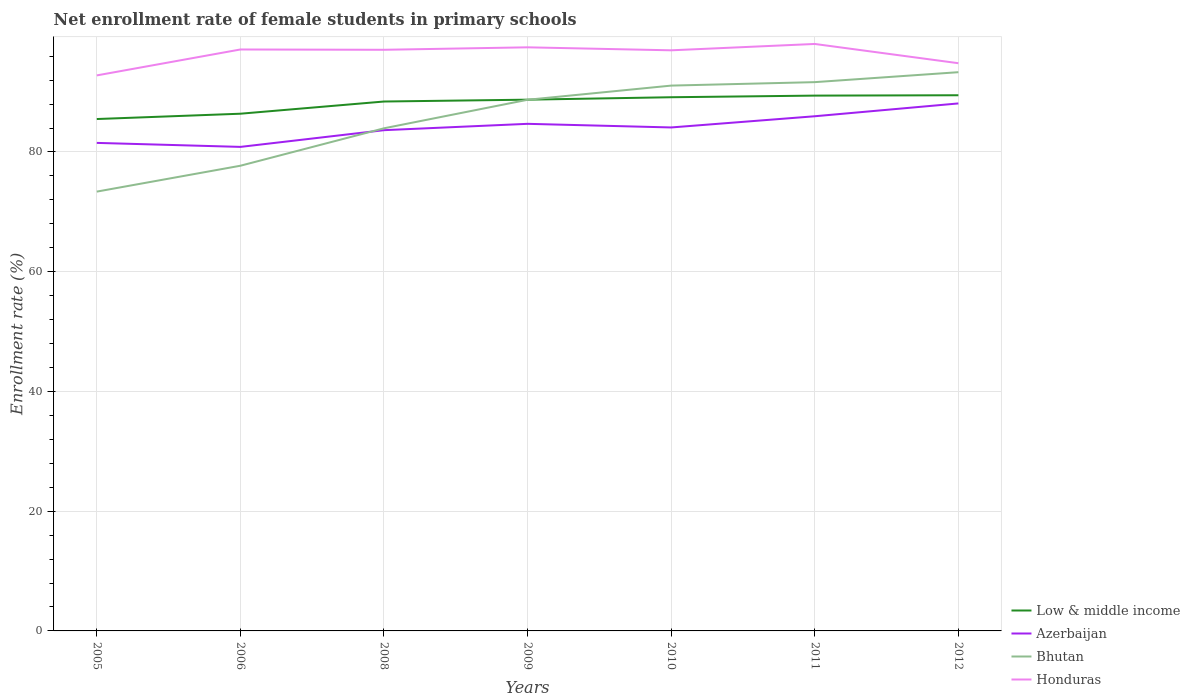How many different coloured lines are there?
Your answer should be very brief. 4. Across all years, what is the maximum net enrollment rate of female students in primary schools in Azerbaijan?
Ensure brevity in your answer.  80.85. In which year was the net enrollment rate of female students in primary schools in Azerbaijan maximum?
Your answer should be very brief. 2006. What is the total net enrollment rate of female students in primary schools in Low & middle income in the graph?
Provide a short and direct response. -3.02. What is the difference between the highest and the second highest net enrollment rate of female students in primary schools in Low & middle income?
Your response must be concise. 3.97. What is the difference between the highest and the lowest net enrollment rate of female students in primary schools in Low & middle income?
Make the answer very short. 5. Is the net enrollment rate of female students in primary schools in Azerbaijan strictly greater than the net enrollment rate of female students in primary schools in Bhutan over the years?
Provide a succinct answer. No. What is the difference between two consecutive major ticks on the Y-axis?
Ensure brevity in your answer.  20. Are the values on the major ticks of Y-axis written in scientific E-notation?
Give a very brief answer. No. Where does the legend appear in the graph?
Give a very brief answer. Bottom right. What is the title of the graph?
Keep it short and to the point. Net enrollment rate of female students in primary schools. What is the label or title of the Y-axis?
Provide a succinct answer. Enrollment rate (%). What is the Enrollment rate (%) of Low & middle income in 2005?
Your answer should be compact. 85.5. What is the Enrollment rate (%) in Azerbaijan in 2005?
Ensure brevity in your answer.  81.52. What is the Enrollment rate (%) of Bhutan in 2005?
Provide a short and direct response. 73.38. What is the Enrollment rate (%) in Honduras in 2005?
Make the answer very short. 92.79. What is the Enrollment rate (%) of Low & middle income in 2006?
Ensure brevity in your answer.  86.39. What is the Enrollment rate (%) in Azerbaijan in 2006?
Provide a succinct answer. 80.85. What is the Enrollment rate (%) in Bhutan in 2006?
Offer a terse response. 77.7. What is the Enrollment rate (%) in Honduras in 2006?
Give a very brief answer. 97.12. What is the Enrollment rate (%) in Low & middle income in 2008?
Make the answer very short. 88.43. What is the Enrollment rate (%) in Azerbaijan in 2008?
Keep it short and to the point. 83.64. What is the Enrollment rate (%) of Bhutan in 2008?
Offer a very short reply. 83.95. What is the Enrollment rate (%) in Honduras in 2008?
Make the answer very short. 97.07. What is the Enrollment rate (%) of Low & middle income in 2009?
Provide a short and direct response. 88.74. What is the Enrollment rate (%) in Azerbaijan in 2009?
Keep it short and to the point. 84.7. What is the Enrollment rate (%) in Bhutan in 2009?
Give a very brief answer. 88.72. What is the Enrollment rate (%) in Honduras in 2009?
Keep it short and to the point. 97.48. What is the Enrollment rate (%) of Low & middle income in 2010?
Keep it short and to the point. 89.14. What is the Enrollment rate (%) in Azerbaijan in 2010?
Your answer should be very brief. 84.09. What is the Enrollment rate (%) in Bhutan in 2010?
Ensure brevity in your answer.  91.09. What is the Enrollment rate (%) in Honduras in 2010?
Keep it short and to the point. 96.98. What is the Enrollment rate (%) in Low & middle income in 2011?
Your response must be concise. 89.41. What is the Enrollment rate (%) of Azerbaijan in 2011?
Provide a succinct answer. 85.97. What is the Enrollment rate (%) of Bhutan in 2011?
Offer a very short reply. 91.66. What is the Enrollment rate (%) in Honduras in 2011?
Offer a terse response. 98.04. What is the Enrollment rate (%) in Low & middle income in 2012?
Keep it short and to the point. 89.47. What is the Enrollment rate (%) of Azerbaijan in 2012?
Your response must be concise. 88.11. What is the Enrollment rate (%) in Bhutan in 2012?
Keep it short and to the point. 93.33. What is the Enrollment rate (%) in Honduras in 2012?
Your response must be concise. 94.82. Across all years, what is the maximum Enrollment rate (%) of Low & middle income?
Keep it short and to the point. 89.47. Across all years, what is the maximum Enrollment rate (%) in Azerbaijan?
Make the answer very short. 88.11. Across all years, what is the maximum Enrollment rate (%) of Bhutan?
Give a very brief answer. 93.33. Across all years, what is the maximum Enrollment rate (%) of Honduras?
Keep it short and to the point. 98.04. Across all years, what is the minimum Enrollment rate (%) of Low & middle income?
Make the answer very short. 85.5. Across all years, what is the minimum Enrollment rate (%) of Azerbaijan?
Give a very brief answer. 80.85. Across all years, what is the minimum Enrollment rate (%) in Bhutan?
Make the answer very short. 73.38. Across all years, what is the minimum Enrollment rate (%) of Honduras?
Make the answer very short. 92.79. What is the total Enrollment rate (%) of Low & middle income in the graph?
Ensure brevity in your answer.  617.08. What is the total Enrollment rate (%) of Azerbaijan in the graph?
Provide a succinct answer. 588.87. What is the total Enrollment rate (%) of Bhutan in the graph?
Keep it short and to the point. 599.83. What is the total Enrollment rate (%) of Honduras in the graph?
Make the answer very short. 674.3. What is the difference between the Enrollment rate (%) of Low & middle income in 2005 and that in 2006?
Give a very brief answer. -0.89. What is the difference between the Enrollment rate (%) of Azerbaijan in 2005 and that in 2006?
Give a very brief answer. 0.67. What is the difference between the Enrollment rate (%) in Bhutan in 2005 and that in 2006?
Provide a succinct answer. -4.32. What is the difference between the Enrollment rate (%) of Honduras in 2005 and that in 2006?
Give a very brief answer. -4.33. What is the difference between the Enrollment rate (%) of Low & middle income in 2005 and that in 2008?
Offer a terse response. -2.93. What is the difference between the Enrollment rate (%) of Azerbaijan in 2005 and that in 2008?
Your answer should be very brief. -2.12. What is the difference between the Enrollment rate (%) in Bhutan in 2005 and that in 2008?
Ensure brevity in your answer.  -10.58. What is the difference between the Enrollment rate (%) in Honduras in 2005 and that in 2008?
Your answer should be very brief. -4.28. What is the difference between the Enrollment rate (%) of Low & middle income in 2005 and that in 2009?
Ensure brevity in your answer.  -3.23. What is the difference between the Enrollment rate (%) in Azerbaijan in 2005 and that in 2009?
Provide a succinct answer. -3.18. What is the difference between the Enrollment rate (%) of Bhutan in 2005 and that in 2009?
Keep it short and to the point. -15.34. What is the difference between the Enrollment rate (%) in Honduras in 2005 and that in 2009?
Your response must be concise. -4.69. What is the difference between the Enrollment rate (%) in Low & middle income in 2005 and that in 2010?
Provide a short and direct response. -3.64. What is the difference between the Enrollment rate (%) in Azerbaijan in 2005 and that in 2010?
Keep it short and to the point. -2.58. What is the difference between the Enrollment rate (%) of Bhutan in 2005 and that in 2010?
Offer a very short reply. -17.71. What is the difference between the Enrollment rate (%) of Honduras in 2005 and that in 2010?
Your answer should be very brief. -4.19. What is the difference between the Enrollment rate (%) in Low & middle income in 2005 and that in 2011?
Provide a succinct answer. -3.91. What is the difference between the Enrollment rate (%) of Azerbaijan in 2005 and that in 2011?
Your answer should be compact. -4.45. What is the difference between the Enrollment rate (%) in Bhutan in 2005 and that in 2011?
Your answer should be very brief. -18.29. What is the difference between the Enrollment rate (%) of Honduras in 2005 and that in 2011?
Ensure brevity in your answer.  -5.25. What is the difference between the Enrollment rate (%) of Low & middle income in 2005 and that in 2012?
Provide a succinct answer. -3.97. What is the difference between the Enrollment rate (%) of Azerbaijan in 2005 and that in 2012?
Your answer should be compact. -6.59. What is the difference between the Enrollment rate (%) in Bhutan in 2005 and that in 2012?
Make the answer very short. -19.95. What is the difference between the Enrollment rate (%) of Honduras in 2005 and that in 2012?
Offer a very short reply. -2.04. What is the difference between the Enrollment rate (%) in Low & middle income in 2006 and that in 2008?
Provide a short and direct response. -2.04. What is the difference between the Enrollment rate (%) of Azerbaijan in 2006 and that in 2008?
Offer a terse response. -2.79. What is the difference between the Enrollment rate (%) of Bhutan in 2006 and that in 2008?
Provide a succinct answer. -6.25. What is the difference between the Enrollment rate (%) in Honduras in 2006 and that in 2008?
Make the answer very short. 0.05. What is the difference between the Enrollment rate (%) of Low & middle income in 2006 and that in 2009?
Offer a very short reply. -2.35. What is the difference between the Enrollment rate (%) of Azerbaijan in 2006 and that in 2009?
Your response must be concise. -3.85. What is the difference between the Enrollment rate (%) in Bhutan in 2006 and that in 2009?
Offer a very short reply. -11.02. What is the difference between the Enrollment rate (%) of Honduras in 2006 and that in 2009?
Your response must be concise. -0.36. What is the difference between the Enrollment rate (%) in Low & middle income in 2006 and that in 2010?
Give a very brief answer. -2.75. What is the difference between the Enrollment rate (%) in Azerbaijan in 2006 and that in 2010?
Provide a succinct answer. -3.25. What is the difference between the Enrollment rate (%) in Bhutan in 2006 and that in 2010?
Your answer should be compact. -13.38. What is the difference between the Enrollment rate (%) in Honduras in 2006 and that in 2010?
Make the answer very short. 0.14. What is the difference between the Enrollment rate (%) in Low & middle income in 2006 and that in 2011?
Your answer should be compact. -3.02. What is the difference between the Enrollment rate (%) in Azerbaijan in 2006 and that in 2011?
Keep it short and to the point. -5.12. What is the difference between the Enrollment rate (%) in Bhutan in 2006 and that in 2011?
Your answer should be very brief. -13.96. What is the difference between the Enrollment rate (%) of Honduras in 2006 and that in 2011?
Provide a short and direct response. -0.92. What is the difference between the Enrollment rate (%) in Low & middle income in 2006 and that in 2012?
Make the answer very short. -3.08. What is the difference between the Enrollment rate (%) of Azerbaijan in 2006 and that in 2012?
Make the answer very short. -7.26. What is the difference between the Enrollment rate (%) in Bhutan in 2006 and that in 2012?
Provide a succinct answer. -15.62. What is the difference between the Enrollment rate (%) of Honduras in 2006 and that in 2012?
Ensure brevity in your answer.  2.29. What is the difference between the Enrollment rate (%) in Low & middle income in 2008 and that in 2009?
Offer a terse response. -0.31. What is the difference between the Enrollment rate (%) in Azerbaijan in 2008 and that in 2009?
Your response must be concise. -1.06. What is the difference between the Enrollment rate (%) of Bhutan in 2008 and that in 2009?
Keep it short and to the point. -4.76. What is the difference between the Enrollment rate (%) in Honduras in 2008 and that in 2009?
Offer a terse response. -0.41. What is the difference between the Enrollment rate (%) of Low & middle income in 2008 and that in 2010?
Make the answer very short. -0.71. What is the difference between the Enrollment rate (%) of Azerbaijan in 2008 and that in 2010?
Your response must be concise. -0.45. What is the difference between the Enrollment rate (%) of Bhutan in 2008 and that in 2010?
Your response must be concise. -7.13. What is the difference between the Enrollment rate (%) of Honduras in 2008 and that in 2010?
Your answer should be compact. 0.09. What is the difference between the Enrollment rate (%) of Low & middle income in 2008 and that in 2011?
Your answer should be compact. -0.99. What is the difference between the Enrollment rate (%) of Azerbaijan in 2008 and that in 2011?
Give a very brief answer. -2.33. What is the difference between the Enrollment rate (%) of Bhutan in 2008 and that in 2011?
Provide a short and direct response. -7.71. What is the difference between the Enrollment rate (%) in Honduras in 2008 and that in 2011?
Ensure brevity in your answer.  -0.97. What is the difference between the Enrollment rate (%) of Low & middle income in 2008 and that in 2012?
Your answer should be very brief. -1.05. What is the difference between the Enrollment rate (%) of Azerbaijan in 2008 and that in 2012?
Offer a terse response. -4.47. What is the difference between the Enrollment rate (%) in Bhutan in 2008 and that in 2012?
Your answer should be very brief. -9.37. What is the difference between the Enrollment rate (%) in Honduras in 2008 and that in 2012?
Offer a terse response. 2.24. What is the difference between the Enrollment rate (%) in Low & middle income in 2009 and that in 2010?
Ensure brevity in your answer.  -0.41. What is the difference between the Enrollment rate (%) of Azerbaijan in 2009 and that in 2010?
Your answer should be compact. 0.61. What is the difference between the Enrollment rate (%) in Bhutan in 2009 and that in 2010?
Offer a terse response. -2.37. What is the difference between the Enrollment rate (%) in Honduras in 2009 and that in 2010?
Your answer should be very brief. 0.5. What is the difference between the Enrollment rate (%) of Low & middle income in 2009 and that in 2011?
Keep it short and to the point. -0.68. What is the difference between the Enrollment rate (%) in Azerbaijan in 2009 and that in 2011?
Make the answer very short. -1.27. What is the difference between the Enrollment rate (%) in Bhutan in 2009 and that in 2011?
Your answer should be very brief. -2.94. What is the difference between the Enrollment rate (%) in Honduras in 2009 and that in 2011?
Provide a succinct answer. -0.56. What is the difference between the Enrollment rate (%) of Low & middle income in 2009 and that in 2012?
Give a very brief answer. -0.74. What is the difference between the Enrollment rate (%) of Azerbaijan in 2009 and that in 2012?
Your answer should be compact. -3.41. What is the difference between the Enrollment rate (%) in Bhutan in 2009 and that in 2012?
Provide a succinct answer. -4.61. What is the difference between the Enrollment rate (%) in Honduras in 2009 and that in 2012?
Offer a very short reply. 2.65. What is the difference between the Enrollment rate (%) of Low & middle income in 2010 and that in 2011?
Ensure brevity in your answer.  -0.27. What is the difference between the Enrollment rate (%) of Azerbaijan in 2010 and that in 2011?
Offer a very short reply. -1.87. What is the difference between the Enrollment rate (%) in Bhutan in 2010 and that in 2011?
Provide a short and direct response. -0.58. What is the difference between the Enrollment rate (%) in Honduras in 2010 and that in 2011?
Your answer should be very brief. -1.06. What is the difference between the Enrollment rate (%) in Low & middle income in 2010 and that in 2012?
Provide a short and direct response. -0.33. What is the difference between the Enrollment rate (%) of Azerbaijan in 2010 and that in 2012?
Offer a very short reply. -4.01. What is the difference between the Enrollment rate (%) in Bhutan in 2010 and that in 2012?
Offer a very short reply. -2.24. What is the difference between the Enrollment rate (%) in Honduras in 2010 and that in 2012?
Give a very brief answer. 2.15. What is the difference between the Enrollment rate (%) in Low & middle income in 2011 and that in 2012?
Ensure brevity in your answer.  -0.06. What is the difference between the Enrollment rate (%) in Azerbaijan in 2011 and that in 2012?
Your answer should be compact. -2.14. What is the difference between the Enrollment rate (%) of Bhutan in 2011 and that in 2012?
Offer a very short reply. -1.66. What is the difference between the Enrollment rate (%) of Honduras in 2011 and that in 2012?
Your answer should be very brief. 3.22. What is the difference between the Enrollment rate (%) in Low & middle income in 2005 and the Enrollment rate (%) in Azerbaijan in 2006?
Your answer should be compact. 4.65. What is the difference between the Enrollment rate (%) of Low & middle income in 2005 and the Enrollment rate (%) of Bhutan in 2006?
Your response must be concise. 7.8. What is the difference between the Enrollment rate (%) in Low & middle income in 2005 and the Enrollment rate (%) in Honduras in 2006?
Offer a very short reply. -11.62. What is the difference between the Enrollment rate (%) in Azerbaijan in 2005 and the Enrollment rate (%) in Bhutan in 2006?
Offer a very short reply. 3.81. What is the difference between the Enrollment rate (%) of Azerbaijan in 2005 and the Enrollment rate (%) of Honduras in 2006?
Ensure brevity in your answer.  -15.6. What is the difference between the Enrollment rate (%) of Bhutan in 2005 and the Enrollment rate (%) of Honduras in 2006?
Offer a terse response. -23.74. What is the difference between the Enrollment rate (%) in Low & middle income in 2005 and the Enrollment rate (%) in Azerbaijan in 2008?
Your answer should be compact. 1.86. What is the difference between the Enrollment rate (%) in Low & middle income in 2005 and the Enrollment rate (%) in Bhutan in 2008?
Give a very brief answer. 1.55. What is the difference between the Enrollment rate (%) of Low & middle income in 2005 and the Enrollment rate (%) of Honduras in 2008?
Give a very brief answer. -11.57. What is the difference between the Enrollment rate (%) in Azerbaijan in 2005 and the Enrollment rate (%) in Bhutan in 2008?
Your response must be concise. -2.44. What is the difference between the Enrollment rate (%) of Azerbaijan in 2005 and the Enrollment rate (%) of Honduras in 2008?
Offer a terse response. -15.55. What is the difference between the Enrollment rate (%) in Bhutan in 2005 and the Enrollment rate (%) in Honduras in 2008?
Ensure brevity in your answer.  -23.69. What is the difference between the Enrollment rate (%) in Low & middle income in 2005 and the Enrollment rate (%) in Azerbaijan in 2009?
Make the answer very short. 0.8. What is the difference between the Enrollment rate (%) in Low & middle income in 2005 and the Enrollment rate (%) in Bhutan in 2009?
Your answer should be very brief. -3.22. What is the difference between the Enrollment rate (%) in Low & middle income in 2005 and the Enrollment rate (%) in Honduras in 2009?
Offer a terse response. -11.98. What is the difference between the Enrollment rate (%) in Azerbaijan in 2005 and the Enrollment rate (%) in Bhutan in 2009?
Your response must be concise. -7.2. What is the difference between the Enrollment rate (%) in Azerbaijan in 2005 and the Enrollment rate (%) in Honduras in 2009?
Your response must be concise. -15.96. What is the difference between the Enrollment rate (%) of Bhutan in 2005 and the Enrollment rate (%) of Honduras in 2009?
Your answer should be very brief. -24.1. What is the difference between the Enrollment rate (%) of Low & middle income in 2005 and the Enrollment rate (%) of Azerbaijan in 2010?
Offer a terse response. 1.41. What is the difference between the Enrollment rate (%) in Low & middle income in 2005 and the Enrollment rate (%) in Bhutan in 2010?
Offer a very short reply. -5.59. What is the difference between the Enrollment rate (%) of Low & middle income in 2005 and the Enrollment rate (%) of Honduras in 2010?
Give a very brief answer. -11.48. What is the difference between the Enrollment rate (%) in Azerbaijan in 2005 and the Enrollment rate (%) in Bhutan in 2010?
Provide a short and direct response. -9.57. What is the difference between the Enrollment rate (%) of Azerbaijan in 2005 and the Enrollment rate (%) of Honduras in 2010?
Keep it short and to the point. -15.46. What is the difference between the Enrollment rate (%) of Bhutan in 2005 and the Enrollment rate (%) of Honduras in 2010?
Provide a succinct answer. -23.6. What is the difference between the Enrollment rate (%) of Low & middle income in 2005 and the Enrollment rate (%) of Azerbaijan in 2011?
Provide a short and direct response. -0.46. What is the difference between the Enrollment rate (%) in Low & middle income in 2005 and the Enrollment rate (%) in Bhutan in 2011?
Your answer should be very brief. -6.16. What is the difference between the Enrollment rate (%) in Low & middle income in 2005 and the Enrollment rate (%) in Honduras in 2011?
Keep it short and to the point. -12.54. What is the difference between the Enrollment rate (%) in Azerbaijan in 2005 and the Enrollment rate (%) in Bhutan in 2011?
Offer a terse response. -10.15. What is the difference between the Enrollment rate (%) in Azerbaijan in 2005 and the Enrollment rate (%) in Honduras in 2011?
Your answer should be compact. -16.52. What is the difference between the Enrollment rate (%) of Bhutan in 2005 and the Enrollment rate (%) of Honduras in 2011?
Offer a very short reply. -24.66. What is the difference between the Enrollment rate (%) of Low & middle income in 2005 and the Enrollment rate (%) of Azerbaijan in 2012?
Your answer should be compact. -2.61. What is the difference between the Enrollment rate (%) of Low & middle income in 2005 and the Enrollment rate (%) of Bhutan in 2012?
Make the answer very short. -7.83. What is the difference between the Enrollment rate (%) in Low & middle income in 2005 and the Enrollment rate (%) in Honduras in 2012?
Offer a very short reply. -9.32. What is the difference between the Enrollment rate (%) of Azerbaijan in 2005 and the Enrollment rate (%) of Bhutan in 2012?
Your response must be concise. -11.81. What is the difference between the Enrollment rate (%) in Azerbaijan in 2005 and the Enrollment rate (%) in Honduras in 2012?
Keep it short and to the point. -13.31. What is the difference between the Enrollment rate (%) of Bhutan in 2005 and the Enrollment rate (%) of Honduras in 2012?
Your answer should be very brief. -21.45. What is the difference between the Enrollment rate (%) of Low & middle income in 2006 and the Enrollment rate (%) of Azerbaijan in 2008?
Keep it short and to the point. 2.75. What is the difference between the Enrollment rate (%) of Low & middle income in 2006 and the Enrollment rate (%) of Bhutan in 2008?
Provide a succinct answer. 2.43. What is the difference between the Enrollment rate (%) in Low & middle income in 2006 and the Enrollment rate (%) in Honduras in 2008?
Offer a terse response. -10.68. What is the difference between the Enrollment rate (%) of Azerbaijan in 2006 and the Enrollment rate (%) of Bhutan in 2008?
Make the answer very short. -3.11. What is the difference between the Enrollment rate (%) of Azerbaijan in 2006 and the Enrollment rate (%) of Honduras in 2008?
Offer a very short reply. -16.22. What is the difference between the Enrollment rate (%) of Bhutan in 2006 and the Enrollment rate (%) of Honduras in 2008?
Keep it short and to the point. -19.37. What is the difference between the Enrollment rate (%) of Low & middle income in 2006 and the Enrollment rate (%) of Azerbaijan in 2009?
Give a very brief answer. 1.69. What is the difference between the Enrollment rate (%) of Low & middle income in 2006 and the Enrollment rate (%) of Bhutan in 2009?
Your answer should be very brief. -2.33. What is the difference between the Enrollment rate (%) in Low & middle income in 2006 and the Enrollment rate (%) in Honduras in 2009?
Your response must be concise. -11.09. What is the difference between the Enrollment rate (%) of Azerbaijan in 2006 and the Enrollment rate (%) of Bhutan in 2009?
Provide a short and direct response. -7.87. What is the difference between the Enrollment rate (%) of Azerbaijan in 2006 and the Enrollment rate (%) of Honduras in 2009?
Your answer should be compact. -16.63. What is the difference between the Enrollment rate (%) in Bhutan in 2006 and the Enrollment rate (%) in Honduras in 2009?
Ensure brevity in your answer.  -19.78. What is the difference between the Enrollment rate (%) in Low & middle income in 2006 and the Enrollment rate (%) in Azerbaijan in 2010?
Offer a very short reply. 2.3. What is the difference between the Enrollment rate (%) of Low & middle income in 2006 and the Enrollment rate (%) of Bhutan in 2010?
Give a very brief answer. -4.7. What is the difference between the Enrollment rate (%) of Low & middle income in 2006 and the Enrollment rate (%) of Honduras in 2010?
Your answer should be very brief. -10.59. What is the difference between the Enrollment rate (%) in Azerbaijan in 2006 and the Enrollment rate (%) in Bhutan in 2010?
Provide a succinct answer. -10.24. What is the difference between the Enrollment rate (%) of Azerbaijan in 2006 and the Enrollment rate (%) of Honduras in 2010?
Provide a succinct answer. -16.13. What is the difference between the Enrollment rate (%) in Bhutan in 2006 and the Enrollment rate (%) in Honduras in 2010?
Offer a very short reply. -19.28. What is the difference between the Enrollment rate (%) in Low & middle income in 2006 and the Enrollment rate (%) in Azerbaijan in 2011?
Offer a very short reply. 0.42. What is the difference between the Enrollment rate (%) of Low & middle income in 2006 and the Enrollment rate (%) of Bhutan in 2011?
Your response must be concise. -5.27. What is the difference between the Enrollment rate (%) of Low & middle income in 2006 and the Enrollment rate (%) of Honduras in 2011?
Keep it short and to the point. -11.65. What is the difference between the Enrollment rate (%) of Azerbaijan in 2006 and the Enrollment rate (%) of Bhutan in 2011?
Your answer should be very brief. -10.82. What is the difference between the Enrollment rate (%) in Azerbaijan in 2006 and the Enrollment rate (%) in Honduras in 2011?
Offer a terse response. -17.19. What is the difference between the Enrollment rate (%) of Bhutan in 2006 and the Enrollment rate (%) of Honduras in 2011?
Offer a very short reply. -20.34. What is the difference between the Enrollment rate (%) in Low & middle income in 2006 and the Enrollment rate (%) in Azerbaijan in 2012?
Provide a short and direct response. -1.72. What is the difference between the Enrollment rate (%) in Low & middle income in 2006 and the Enrollment rate (%) in Bhutan in 2012?
Ensure brevity in your answer.  -6.94. What is the difference between the Enrollment rate (%) of Low & middle income in 2006 and the Enrollment rate (%) of Honduras in 2012?
Offer a terse response. -8.43. What is the difference between the Enrollment rate (%) of Azerbaijan in 2006 and the Enrollment rate (%) of Bhutan in 2012?
Your answer should be compact. -12.48. What is the difference between the Enrollment rate (%) in Azerbaijan in 2006 and the Enrollment rate (%) in Honduras in 2012?
Make the answer very short. -13.98. What is the difference between the Enrollment rate (%) in Bhutan in 2006 and the Enrollment rate (%) in Honduras in 2012?
Offer a terse response. -17.12. What is the difference between the Enrollment rate (%) of Low & middle income in 2008 and the Enrollment rate (%) of Azerbaijan in 2009?
Keep it short and to the point. 3.73. What is the difference between the Enrollment rate (%) of Low & middle income in 2008 and the Enrollment rate (%) of Bhutan in 2009?
Offer a very short reply. -0.29. What is the difference between the Enrollment rate (%) of Low & middle income in 2008 and the Enrollment rate (%) of Honduras in 2009?
Offer a terse response. -9.05. What is the difference between the Enrollment rate (%) of Azerbaijan in 2008 and the Enrollment rate (%) of Bhutan in 2009?
Offer a terse response. -5.08. What is the difference between the Enrollment rate (%) in Azerbaijan in 2008 and the Enrollment rate (%) in Honduras in 2009?
Your answer should be very brief. -13.84. What is the difference between the Enrollment rate (%) of Bhutan in 2008 and the Enrollment rate (%) of Honduras in 2009?
Give a very brief answer. -13.52. What is the difference between the Enrollment rate (%) of Low & middle income in 2008 and the Enrollment rate (%) of Azerbaijan in 2010?
Provide a succinct answer. 4.33. What is the difference between the Enrollment rate (%) in Low & middle income in 2008 and the Enrollment rate (%) in Bhutan in 2010?
Ensure brevity in your answer.  -2.66. What is the difference between the Enrollment rate (%) in Low & middle income in 2008 and the Enrollment rate (%) in Honduras in 2010?
Ensure brevity in your answer.  -8.55. What is the difference between the Enrollment rate (%) of Azerbaijan in 2008 and the Enrollment rate (%) of Bhutan in 2010?
Your response must be concise. -7.45. What is the difference between the Enrollment rate (%) of Azerbaijan in 2008 and the Enrollment rate (%) of Honduras in 2010?
Offer a terse response. -13.34. What is the difference between the Enrollment rate (%) of Bhutan in 2008 and the Enrollment rate (%) of Honduras in 2010?
Provide a succinct answer. -13.02. What is the difference between the Enrollment rate (%) of Low & middle income in 2008 and the Enrollment rate (%) of Azerbaijan in 2011?
Offer a terse response. 2.46. What is the difference between the Enrollment rate (%) in Low & middle income in 2008 and the Enrollment rate (%) in Bhutan in 2011?
Your answer should be very brief. -3.24. What is the difference between the Enrollment rate (%) in Low & middle income in 2008 and the Enrollment rate (%) in Honduras in 2011?
Keep it short and to the point. -9.61. What is the difference between the Enrollment rate (%) of Azerbaijan in 2008 and the Enrollment rate (%) of Bhutan in 2011?
Keep it short and to the point. -8.02. What is the difference between the Enrollment rate (%) in Azerbaijan in 2008 and the Enrollment rate (%) in Honduras in 2011?
Offer a very short reply. -14.4. What is the difference between the Enrollment rate (%) in Bhutan in 2008 and the Enrollment rate (%) in Honduras in 2011?
Give a very brief answer. -14.09. What is the difference between the Enrollment rate (%) in Low & middle income in 2008 and the Enrollment rate (%) in Azerbaijan in 2012?
Provide a succinct answer. 0.32. What is the difference between the Enrollment rate (%) of Low & middle income in 2008 and the Enrollment rate (%) of Bhutan in 2012?
Ensure brevity in your answer.  -4.9. What is the difference between the Enrollment rate (%) in Low & middle income in 2008 and the Enrollment rate (%) in Honduras in 2012?
Keep it short and to the point. -6.4. What is the difference between the Enrollment rate (%) in Azerbaijan in 2008 and the Enrollment rate (%) in Bhutan in 2012?
Give a very brief answer. -9.69. What is the difference between the Enrollment rate (%) in Azerbaijan in 2008 and the Enrollment rate (%) in Honduras in 2012?
Offer a terse response. -11.18. What is the difference between the Enrollment rate (%) in Bhutan in 2008 and the Enrollment rate (%) in Honduras in 2012?
Provide a succinct answer. -10.87. What is the difference between the Enrollment rate (%) of Low & middle income in 2009 and the Enrollment rate (%) of Azerbaijan in 2010?
Offer a terse response. 4.64. What is the difference between the Enrollment rate (%) in Low & middle income in 2009 and the Enrollment rate (%) in Bhutan in 2010?
Your answer should be very brief. -2.35. What is the difference between the Enrollment rate (%) in Low & middle income in 2009 and the Enrollment rate (%) in Honduras in 2010?
Your answer should be very brief. -8.24. What is the difference between the Enrollment rate (%) of Azerbaijan in 2009 and the Enrollment rate (%) of Bhutan in 2010?
Ensure brevity in your answer.  -6.39. What is the difference between the Enrollment rate (%) of Azerbaijan in 2009 and the Enrollment rate (%) of Honduras in 2010?
Ensure brevity in your answer.  -12.28. What is the difference between the Enrollment rate (%) in Bhutan in 2009 and the Enrollment rate (%) in Honduras in 2010?
Your response must be concise. -8.26. What is the difference between the Enrollment rate (%) in Low & middle income in 2009 and the Enrollment rate (%) in Azerbaijan in 2011?
Make the answer very short. 2.77. What is the difference between the Enrollment rate (%) of Low & middle income in 2009 and the Enrollment rate (%) of Bhutan in 2011?
Your answer should be very brief. -2.93. What is the difference between the Enrollment rate (%) in Low & middle income in 2009 and the Enrollment rate (%) in Honduras in 2011?
Provide a short and direct response. -9.31. What is the difference between the Enrollment rate (%) in Azerbaijan in 2009 and the Enrollment rate (%) in Bhutan in 2011?
Give a very brief answer. -6.96. What is the difference between the Enrollment rate (%) in Azerbaijan in 2009 and the Enrollment rate (%) in Honduras in 2011?
Your answer should be compact. -13.34. What is the difference between the Enrollment rate (%) in Bhutan in 2009 and the Enrollment rate (%) in Honduras in 2011?
Make the answer very short. -9.32. What is the difference between the Enrollment rate (%) in Low & middle income in 2009 and the Enrollment rate (%) in Azerbaijan in 2012?
Ensure brevity in your answer.  0.63. What is the difference between the Enrollment rate (%) of Low & middle income in 2009 and the Enrollment rate (%) of Bhutan in 2012?
Ensure brevity in your answer.  -4.59. What is the difference between the Enrollment rate (%) in Low & middle income in 2009 and the Enrollment rate (%) in Honduras in 2012?
Your response must be concise. -6.09. What is the difference between the Enrollment rate (%) of Azerbaijan in 2009 and the Enrollment rate (%) of Bhutan in 2012?
Your response must be concise. -8.63. What is the difference between the Enrollment rate (%) in Azerbaijan in 2009 and the Enrollment rate (%) in Honduras in 2012?
Make the answer very short. -10.12. What is the difference between the Enrollment rate (%) in Bhutan in 2009 and the Enrollment rate (%) in Honduras in 2012?
Ensure brevity in your answer.  -6.1. What is the difference between the Enrollment rate (%) of Low & middle income in 2010 and the Enrollment rate (%) of Azerbaijan in 2011?
Provide a short and direct response. 3.18. What is the difference between the Enrollment rate (%) in Low & middle income in 2010 and the Enrollment rate (%) in Bhutan in 2011?
Your response must be concise. -2.52. What is the difference between the Enrollment rate (%) in Low & middle income in 2010 and the Enrollment rate (%) in Honduras in 2011?
Your response must be concise. -8.9. What is the difference between the Enrollment rate (%) of Azerbaijan in 2010 and the Enrollment rate (%) of Bhutan in 2011?
Provide a short and direct response. -7.57. What is the difference between the Enrollment rate (%) of Azerbaijan in 2010 and the Enrollment rate (%) of Honduras in 2011?
Ensure brevity in your answer.  -13.95. What is the difference between the Enrollment rate (%) of Bhutan in 2010 and the Enrollment rate (%) of Honduras in 2011?
Your answer should be compact. -6.96. What is the difference between the Enrollment rate (%) of Low & middle income in 2010 and the Enrollment rate (%) of Azerbaijan in 2012?
Your answer should be compact. 1.03. What is the difference between the Enrollment rate (%) in Low & middle income in 2010 and the Enrollment rate (%) in Bhutan in 2012?
Your response must be concise. -4.18. What is the difference between the Enrollment rate (%) in Low & middle income in 2010 and the Enrollment rate (%) in Honduras in 2012?
Ensure brevity in your answer.  -5.68. What is the difference between the Enrollment rate (%) in Azerbaijan in 2010 and the Enrollment rate (%) in Bhutan in 2012?
Your answer should be very brief. -9.23. What is the difference between the Enrollment rate (%) of Azerbaijan in 2010 and the Enrollment rate (%) of Honduras in 2012?
Your answer should be compact. -10.73. What is the difference between the Enrollment rate (%) of Bhutan in 2010 and the Enrollment rate (%) of Honduras in 2012?
Your answer should be compact. -3.74. What is the difference between the Enrollment rate (%) in Low & middle income in 2011 and the Enrollment rate (%) in Azerbaijan in 2012?
Offer a terse response. 1.31. What is the difference between the Enrollment rate (%) of Low & middle income in 2011 and the Enrollment rate (%) of Bhutan in 2012?
Your answer should be very brief. -3.91. What is the difference between the Enrollment rate (%) of Low & middle income in 2011 and the Enrollment rate (%) of Honduras in 2012?
Your response must be concise. -5.41. What is the difference between the Enrollment rate (%) in Azerbaijan in 2011 and the Enrollment rate (%) in Bhutan in 2012?
Provide a succinct answer. -7.36. What is the difference between the Enrollment rate (%) in Azerbaijan in 2011 and the Enrollment rate (%) in Honduras in 2012?
Ensure brevity in your answer.  -8.86. What is the difference between the Enrollment rate (%) in Bhutan in 2011 and the Enrollment rate (%) in Honduras in 2012?
Your response must be concise. -3.16. What is the average Enrollment rate (%) in Low & middle income per year?
Provide a short and direct response. 88.15. What is the average Enrollment rate (%) of Azerbaijan per year?
Make the answer very short. 84.12. What is the average Enrollment rate (%) in Bhutan per year?
Provide a succinct answer. 85.69. What is the average Enrollment rate (%) of Honduras per year?
Give a very brief answer. 96.33. In the year 2005, what is the difference between the Enrollment rate (%) of Low & middle income and Enrollment rate (%) of Azerbaijan?
Ensure brevity in your answer.  3.98. In the year 2005, what is the difference between the Enrollment rate (%) in Low & middle income and Enrollment rate (%) in Bhutan?
Offer a terse response. 12.12. In the year 2005, what is the difference between the Enrollment rate (%) in Low & middle income and Enrollment rate (%) in Honduras?
Provide a succinct answer. -7.29. In the year 2005, what is the difference between the Enrollment rate (%) of Azerbaijan and Enrollment rate (%) of Bhutan?
Make the answer very short. 8.14. In the year 2005, what is the difference between the Enrollment rate (%) of Azerbaijan and Enrollment rate (%) of Honduras?
Offer a very short reply. -11.27. In the year 2005, what is the difference between the Enrollment rate (%) of Bhutan and Enrollment rate (%) of Honduras?
Ensure brevity in your answer.  -19.41. In the year 2006, what is the difference between the Enrollment rate (%) of Low & middle income and Enrollment rate (%) of Azerbaijan?
Ensure brevity in your answer.  5.54. In the year 2006, what is the difference between the Enrollment rate (%) in Low & middle income and Enrollment rate (%) in Bhutan?
Offer a terse response. 8.69. In the year 2006, what is the difference between the Enrollment rate (%) of Low & middle income and Enrollment rate (%) of Honduras?
Keep it short and to the point. -10.73. In the year 2006, what is the difference between the Enrollment rate (%) in Azerbaijan and Enrollment rate (%) in Bhutan?
Your response must be concise. 3.15. In the year 2006, what is the difference between the Enrollment rate (%) in Azerbaijan and Enrollment rate (%) in Honduras?
Offer a very short reply. -16.27. In the year 2006, what is the difference between the Enrollment rate (%) of Bhutan and Enrollment rate (%) of Honduras?
Provide a short and direct response. -19.42. In the year 2008, what is the difference between the Enrollment rate (%) in Low & middle income and Enrollment rate (%) in Azerbaijan?
Give a very brief answer. 4.79. In the year 2008, what is the difference between the Enrollment rate (%) of Low & middle income and Enrollment rate (%) of Bhutan?
Provide a succinct answer. 4.47. In the year 2008, what is the difference between the Enrollment rate (%) of Low & middle income and Enrollment rate (%) of Honduras?
Provide a succinct answer. -8.64. In the year 2008, what is the difference between the Enrollment rate (%) of Azerbaijan and Enrollment rate (%) of Bhutan?
Your answer should be very brief. -0.31. In the year 2008, what is the difference between the Enrollment rate (%) of Azerbaijan and Enrollment rate (%) of Honduras?
Ensure brevity in your answer.  -13.43. In the year 2008, what is the difference between the Enrollment rate (%) in Bhutan and Enrollment rate (%) in Honduras?
Your answer should be compact. -13.11. In the year 2009, what is the difference between the Enrollment rate (%) of Low & middle income and Enrollment rate (%) of Azerbaijan?
Your answer should be compact. 4.04. In the year 2009, what is the difference between the Enrollment rate (%) in Low & middle income and Enrollment rate (%) in Bhutan?
Make the answer very short. 0.02. In the year 2009, what is the difference between the Enrollment rate (%) in Low & middle income and Enrollment rate (%) in Honduras?
Your answer should be compact. -8.74. In the year 2009, what is the difference between the Enrollment rate (%) of Azerbaijan and Enrollment rate (%) of Bhutan?
Offer a terse response. -4.02. In the year 2009, what is the difference between the Enrollment rate (%) of Azerbaijan and Enrollment rate (%) of Honduras?
Give a very brief answer. -12.78. In the year 2009, what is the difference between the Enrollment rate (%) in Bhutan and Enrollment rate (%) in Honduras?
Give a very brief answer. -8.76. In the year 2010, what is the difference between the Enrollment rate (%) in Low & middle income and Enrollment rate (%) in Azerbaijan?
Your response must be concise. 5.05. In the year 2010, what is the difference between the Enrollment rate (%) in Low & middle income and Enrollment rate (%) in Bhutan?
Make the answer very short. -1.94. In the year 2010, what is the difference between the Enrollment rate (%) in Low & middle income and Enrollment rate (%) in Honduras?
Provide a short and direct response. -7.84. In the year 2010, what is the difference between the Enrollment rate (%) in Azerbaijan and Enrollment rate (%) in Bhutan?
Your response must be concise. -6.99. In the year 2010, what is the difference between the Enrollment rate (%) in Azerbaijan and Enrollment rate (%) in Honduras?
Provide a succinct answer. -12.88. In the year 2010, what is the difference between the Enrollment rate (%) in Bhutan and Enrollment rate (%) in Honduras?
Your response must be concise. -5.89. In the year 2011, what is the difference between the Enrollment rate (%) of Low & middle income and Enrollment rate (%) of Azerbaijan?
Keep it short and to the point. 3.45. In the year 2011, what is the difference between the Enrollment rate (%) in Low & middle income and Enrollment rate (%) in Bhutan?
Give a very brief answer. -2.25. In the year 2011, what is the difference between the Enrollment rate (%) in Low & middle income and Enrollment rate (%) in Honduras?
Give a very brief answer. -8.63. In the year 2011, what is the difference between the Enrollment rate (%) of Azerbaijan and Enrollment rate (%) of Bhutan?
Make the answer very short. -5.7. In the year 2011, what is the difference between the Enrollment rate (%) of Azerbaijan and Enrollment rate (%) of Honduras?
Your answer should be very brief. -12.08. In the year 2011, what is the difference between the Enrollment rate (%) of Bhutan and Enrollment rate (%) of Honduras?
Provide a succinct answer. -6.38. In the year 2012, what is the difference between the Enrollment rate (%) of Low & middle income and Enrollment rate (%) of Azerbaijan?
Your response must be concise. 1.37. In the year 2012, what is the difference between the Enrollment rate (%) of Low & middle income and Enrollment rate (%) of Bhutan?
Your answer should be compact. -3.85. In the year 2012, what is the difference between the Enrollment rate (%) of Low & middle income and Enrollment rate (%) of Honduras?
Your response must be concise. -5.35. In the year 2012, what is the difference between the Enrollment rate (%) in Azerbaijan and Enrollment rate (%) in Bhutan?
Provide a succinct answer. -5.22. In the year 2012, what is the difference between the Enrollment rate (%) of Azerbaijan and Enrollment rate (%) of Honduras?
Your answer should be compact. -6.72. In the year 2012, what is the difference between the Enrollment rate (%) in Bhutan and Enrollment rate (%) in Honduras?
Keep it short and to the point. -1.5. What is the ratio of the Enrollment rate (%) of Azerbaijan in 2005 to that in 2006?
Ensure brevity in your answer.  1.01. What is the ratio of the Enrollment rate (%) of Honduras in 2005 to that in 2006?
Give a very brief answer. 0.96. What is the ratio of the Enrollment rate (%) in Low & middle income in 2005 to that in 2008?
Your answer should be compact. 0.97. What is the ratio of the Enrollment rate (%) of Azerbaijan in 2005 to that in 2008?
Provide a short and direct response. 0.97. What is the ratio of the Enrollment rate (%) in Bhutan in 2005 to that in 2008?
Keep it short and to the point. 0.87. What is the ratio of the Enrollment rate (%) of Honduras in 2005 to that in 2008?
Offer a terse response. 0.96. What is the ratio of the Enrollment rate (%) of Low & middle income in 2005 to that in 2009?
Give a very brief answer. 0.96. What is the ratio of the Enrollment rate (%) of Azerbaijan in 2005 to that in 2009?
Offer a very short reply. 0.96. What is the ratio of the Enrollment rate (%) of Bhutan in 2005 to that in 2009?
Keep it short and to the point. 0.83. What is the ratio of the Enrollment rate (%) of Honduras in 2005 to that in 2009?
Offer a terse response. 0.95. What is the ratio of the Enrollment rate (%) of Low & middle income in 2005 to that in 2010?
Provide a short and direct response. 0.96. What is the ratio of the Enrollment rate (%) of Azerbaijan in 2005 to that in 2010?
Your answer should be very brief. 0.97. What is the ratio of the Enrollment rate (%) of Bhutan in 2005 to that in 2010?
Offer a terse response. 0.81. What is the ratio of the Enrollment rate (%) in Honduras in 2005 to that in 2010?
Your response must be concise. 0.96. What is the ratio of the Enrollment rate (%) of Low & middle income in 2005 to that in 2011?
Offer a very short reply. 0.96. What is the ratio of the Enrollment rate (%) in Azerbaijan in 2005 to that in 2011?
Your answer should be compact. 0.95. What is the ratio of the Enrollment rate (%) of Bhutan in 2005 to that in 2011?
Give a very brief answer. 0.8. What is the ratio of the Enrollment rate (%) in Honduras in 2005 to that in 2011?
Provide a succinct answer. 0.95. What is the ratio of the Enrollment rate (%) in Low & middle income in 2005 to that in 2012?
Give a very brief answer. 0.96. What is the ratio of the Enrollment rate (%) in Azerbaijan in 2005 to that in 2012?
Your response must be concise. 0.93. What is the ratio of the Enrollment rate (%) in Bhutan in 2005 to that in 2012?
Offer a very short reply. 0.79. What is the ratio of the Enrollment rate (%) in Honduras in 2005 to that in 2012?
Your response must be concise. 0.98. What is the ratio of the Enrollment rate (%) in Azerbaijan in 2006 to that in 2008?
Your answer should be very brief. 0.97. What is the ratio of the Enrollment rate (%) of Bhutan in 2006 to that in 2008?
Offer a terse response. 0.93. What is the ratio of the Enrollment rate (%) in Honduras in 2006 to that in 2008?
Your response must be concise. 1. What is the ratio of the Enrollment rate (%) of Low & middle income in 2006 to that in 2009?
Your answer should be very brief. 0.97. What is the ratio of the Enrollment rate (%) in Azerbaijan in 2006 to that in 2009?
Provide a short and direct response. 0.95. What is the ratio of the Enrollment rate (%) in Bhutan in 2006 to that in 2009?
Your answer should be very brief. 0.88. What is the ratio of the Enrollment rate (%) in Low & middle income in 2006 to that in 2010?
Keep it short and to the point. 0.97. What is the ratio of the Enrollment rate (%) of Azerbaijan in 2006 to that in 2010?
Offer a very short reply. 0.96. What is the ratio of the Enrollment rate (%) in Bhutan in 2006 to that in 2010?
Your answer should be very brief. 0.85. What is the ratio of the Enrollment rate (%) in Honduras in 2006 to that in 2010?
Keep it short and to the point. 1. What is the ratio of the Enrollment rate (%) in Low & middle income in 2006 to that in 2011?
Offer a very short reply. 0.97. What is the ratio of the Enrollment rate (%) in Azerbaijan in 2006 to that in 2011?
Provide a short and direct response. 0.94. What is the ratio of the Enrollment rate (%) of Bhutan in 2006 to that in 2011?
Your answer should be compact. 0.85. What is the ratio of the Enrollment rate (%) in Honduras in 2006 to that in 2011?
Make the answer very short. 0.99. What is the ratio of the Enrollment rate (%) of Low & middle income in 2006 to that in 2012?
Your answer should be compact. 0.97. What is the ratio of the Enrollment rate (%) of Azerbaijan in 2006 to that in 2012?
Keep it short and to the point. 0.92. What is the ratio of the Enrollment rate (%) in Bhutan in 2006 to that in 2012?
Offer a very short reply. 0.83. What is the ratio of the Enrollment rate (%) in Honduras in 2006 to that in 2012?
Provide a short and direct response. 1.02. What is the ratio of the Enrollment rate (%) in Low & middle income in 2008 to that in 2009?
Offer a very short reply. 1. What is the ratio of the Enrollment rate (%) of Azerbaijan in 2008 to that in 2009?
Your response must be concise. 0.99. What is the ratio of the Enrollment rate (%) of Bhutan in 2008 to that in 2009?
Make the answer very short. 0.95. What is the ratio of the Enrollment rate (%) of Bhutan in 2008 to that in 2010?
Provide a succinct answer. 0.92. What is the ratio of the Enrollment rate (%) in Bhutan in 2008 to that in 2011?
Give a very brief answer. 0.92. What is the ratio of the Enrollment rate (%) of Low & middle income in 2008 to that in 2012?
Your response must be concise. 0.99. What is the ratio of the Enrollment rate (%) of Azerbaijan in 2008 to that in 2012?
Ensure brevity in your answer.  0.95. What is the ratio of the Enrollment rate (%) of Bhutan in 2008 to that in 2012?
Provide a succinct answer. 0.9. What is the ratio of the Enrollment rate (%) in Honduras in 2008 to that in 2012?
Give a very brief answer. 1.02. What is the ratio of the Enrollment rate (%) of Azerbaijan in 2009 to that in 2010?
Your response must be concise. 1.01. What is the ratio of the Enrollment rate (%) of Bhutan in 2009 to that in 2010?
Make the answer very short. 0.97. What is the ratio of the Enrollment rate (%) of Honduras in 2009 to that in 2010?
Offer a very short reply. 1.01. What is the ratio of the Enrollment rate (%) of Bhutan in 2009 to that in 2011?
Provide a short and direct response. 0.97. What is the ratio of the Enrollment rate (%) of Azerbaijan in 2009 to that in 2012?
Your answer should be very brief. 0.96. What is the ratio of the Enrollment rate (%) in Bhutan in 2009 to that in 2012?
Provide a succinct answer. 0.95. What is the ratio of the Enrollment rate (%) in Honduras in 2009 to that in 2012?
Offer a terse response. 1.03. What is the ratio of the Enrollment rate (%) in Low & middle income in 2010 to that in 2011?
Offer a terse response. 1. What is the ratio of the Enrollment rate (%) of Azerbaijan in 2010 to that in 2011?
Ensure brevity in your answer.  0.98. What is the ratio of the Enrollment rate (%) of Bhutan in 2010 to that in 2011?
Your answer should be compact. 0.99. What is the ratio of the Enrollment rate (%) in Azerbaijan in 2010 to that in 2012?
Your response must be concise. 0.95. What is the ratio of the Enrollment rate (%) in Bhutan in 2010 to that in 2012?
Your response must be concise. 0.98. What is the ratio of the Enrollment rate (%) of Honduras in 2010 to that in 2012?
Make the answer very short. 1.02. What is the ratio of the Enrollment rate (%) in Low & middle income in 2011 to that in 2012?
Make the answer very short. 1. What is the ratio of the Enrollment rate (%) in Azerbaijan in 2011 to that in 2012?
Provide a succinct answer. 0.98. What is the ratio of the Enrollment rate (%) in Bhutan in 2011 to that in 2012?
Give a very brief answer. 0.98. What is the ratio of the Enrollment rate (%) of Honduras in 2011 to that in 2012?
Keep it short and to the point. 1.03. What is the difference between the highest and the second highest Enrollment rate (%) in Azerbaijan?
Keep it short and to the point. 2.14. What is the difference between the highest and the second highest Enrollment rate (%) in Bhutan?
Your answer should be very brief. 1.66. What is the difference between the highest and the second highest Enrollment rate (%) of Honduras?
Your response must be concise. 0.56. What is the difference between the highest and the lowest Enrollment rate (%) of Low & middle income?
Offer a very short reply. 3.97. What is the difference between the highest and the lowest Enrollment rate (%) in Azerbaijan?
Your answer should be compact. 7.26. What is the difference between the highest and the lowest Enrollment rate (%) in Bhutan?
Make the answer very short. 19.95. What is the difference between the highest and the lowest Enrollment rate (%) in Honduras?
Provide a succinct answer. 5.25. 